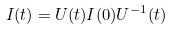<formula> <loc_0><loc_0><loc_500><loc_500>I ( t ) = U ( t ) I ( 0 ) U ^ { - 1 } ( t )</formula> 